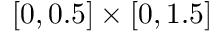<formula> <loc_0><loc_0><loc_500><loc_500>[ 0 , 0 . 5 ] \times [ 0 , 1 . 5 ]</formula> 